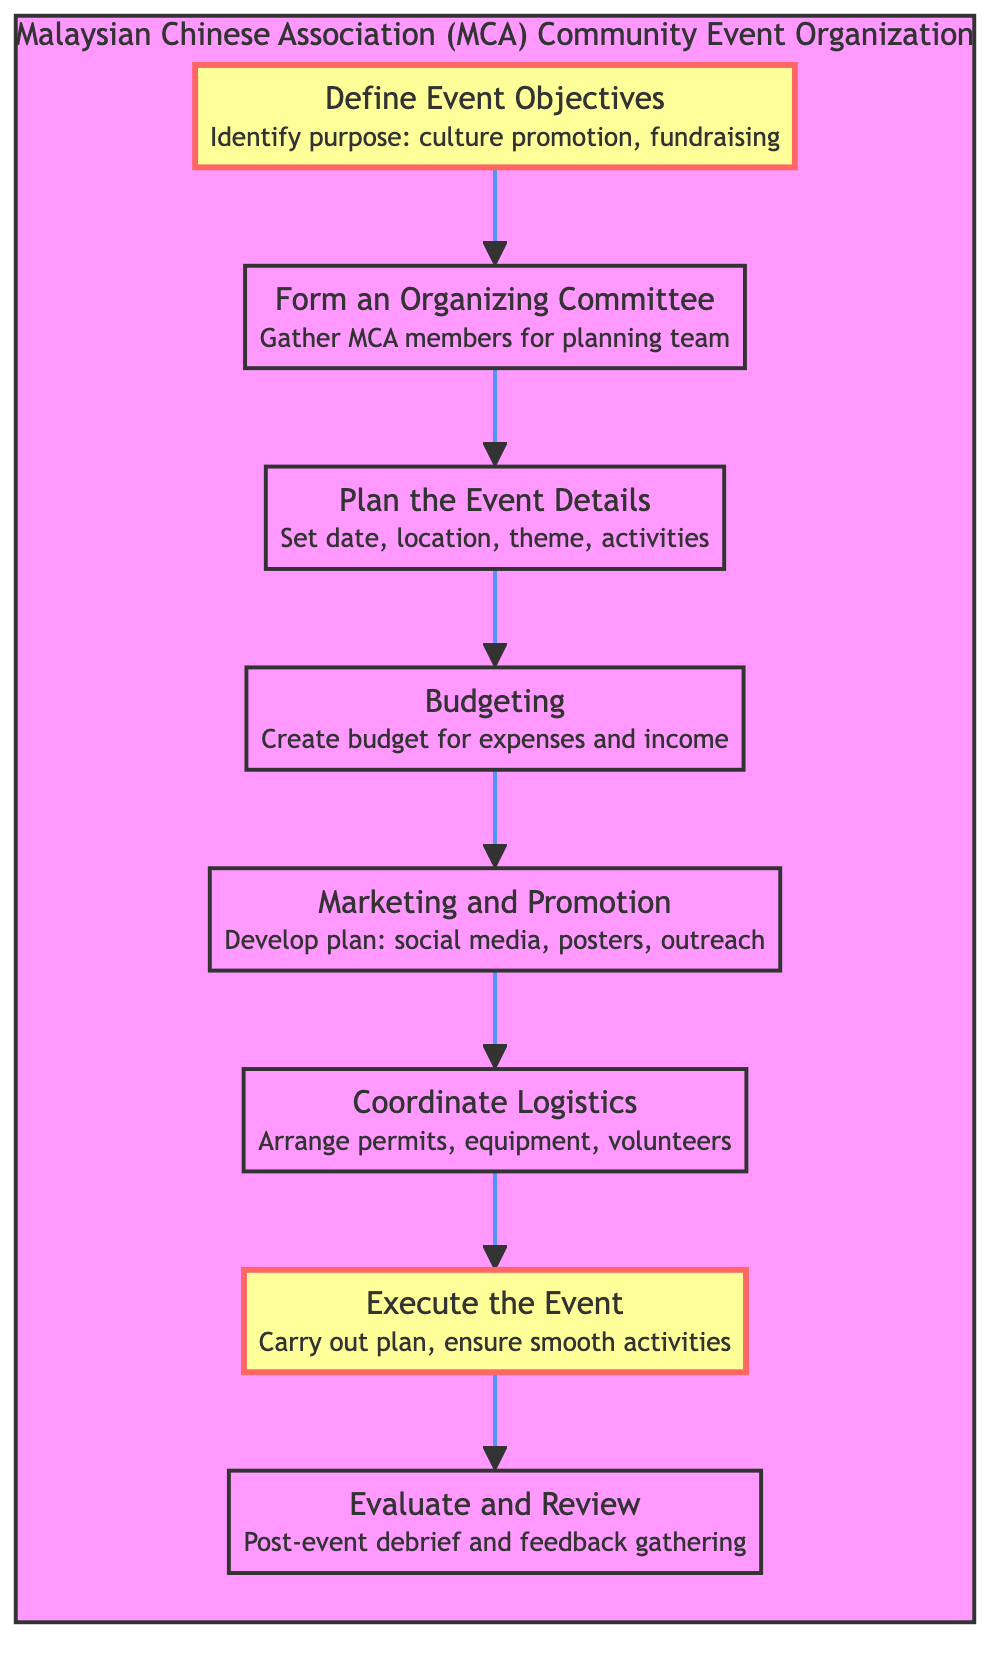What is the first step in the event organization process? The first step is indicated at the top of the flow chart, leading to the next step. It is clearly labeled "Define Event Objectives."
Answer: Define Event Objectives How many steps are involved in organizing the event? By counting the steps in the flowchart, there are a total of eight distinct nodes listed sequentially from the start to the end.
Answer: 8 What is the last step in the organization process? The last node represents the final action in the sequence, which is labeled "Evaluate and Review." It comes after the execution of the event.
Answer: Evaluate and Review What is the main purpose of "Budgeting"? Each step has a brief description attached to it. The description of "Budgeting" specifically mentions creating a budget for expenses and income.
Answer: Create budget for expenses and income Which step immediately follows "Marketing and Promotion"? Referring to the flow of the diagram, "Coordinate Logistics" comes directly after "Marketing and Promotion" in the sequence of steps.
Answer: Coordinate Logistics How many steps occur before "Execute the Event"? To determine this, we count the steps leading up to "Execute the Event," which are a total of six steps: Define Event Objectives, Form an Organizing Committee, Plan the Event Details, Budgeting, and Marketing and Promotion.
Answer: 6 What is the focus of the "Marketing and Promotion" step? The flowchart provides a description for each step. The description for "Marketing and Promotion" emphasizes developing a marketing plan using social media, posters, and outreach activities to promote the event.
Answer: Develop plan: social media, posters, outreach What relationship exists between "Plan the Event Details" and "Budgeting"? The diagram depicts a direct flow where "Plan the Event Details" leads to "Budgeting," indicating a sequential relationship where planning precedes financial considerations.
Answer: Sequential relationship What is the purpose of conducting an "Evaluate and Review"? The purpose of this step, as described in the diagram, is to conduct a post-event debrief to assess the event's success and gather feedback for planning future events.
Answer: Post-event debrief and feedback gathering 